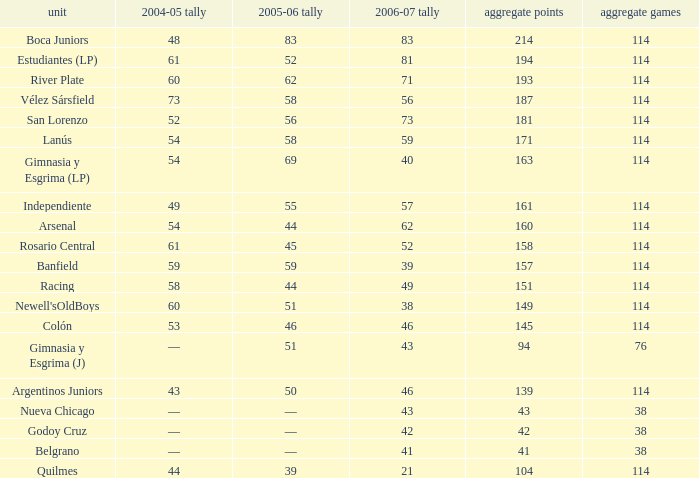Parse the table in full. {'header': ['unit', '2004-05 tally', '2005-06 tally', '2006-07 tally', 'aggregate points', 'aggregate games'], 'rows': [['Boca Juniors', '48', '83', '83', '214', '114'], ['Estudiantes (LP)', '61', '52', '81', '194', '114'], ['River Plate', '60', '62', '71', '193', '114'], ['Vélez Sársfield', '73', '58', '56', '187', '114'], ['San Lorenzo', '52', '56', '73', '181', '114'], ['Lanús', '54', '58', '59', '171', '114'], ['Gimnasia y Esgrima (LP)', '54', '69', '40', '163', '114'], ['Independiente', '49', '55', '57', '161', '114'], ['Arsenal', '54', '44', '62', '160', '114'], ['Rosario Central', '61', '45', '52', '158', '114'], ['Banfield', '59', '59', '39', '157', '114'], ['Racing', '58', '44', '49', '151', '114'], ["Newell'sOldBoys", '60', '51', '38', '149', '114'], ['Colón', '53', '46', '46', '145', '114'], ['Gimnasia y Esgrima (J)', '—', '51', '43', '94', '76'], ['Argentinos Juniors', '43', '50', '46', '139', '114'], ['Nueva Chicago', '—', '—', '43', '43', '38'], ['Godoy Cruz', '—', '—', '42', '42', '38'], ['Belgrano', '—', '—', '41', '41', '38'], ['Quilmes', '44', '39', '21', '104', '114']]} What is the total number of PLD for Team Arsenal? 1.0. 